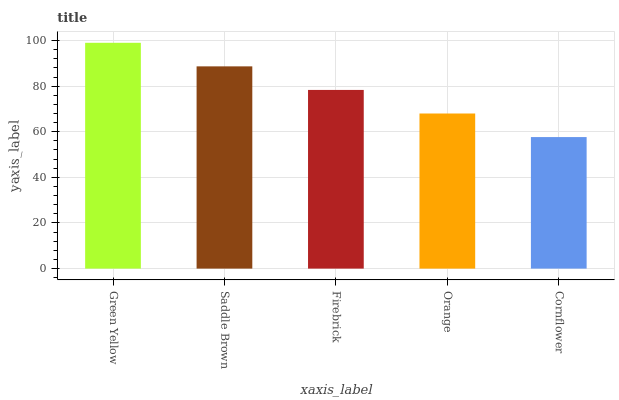Is Cornflower the minimum?
Answer yes or no. Yes. Is Green Yellow the maximum?
Answer yes or no. Yes. Is Saddle Brown the minimum?
Answer yes or no. No. Is Saddle Brown the maximum?
Answer yes or no. No. Is Green Yellow greater than Saddle Brown?
Answer yes or no. Yes. Is Saddle Brown less than Green Yellow?
Answer yes or no. Yes. Is Saddle Brown greater than Green Yellow?
Answer yes or no. No. Is Green Yellow less than Saddle Brown?
Answer yes or no. No. Is Firebrick the high median?
Answer yes or no. Yes. Is Firebrick the low median?
Answer yes or no. Yes. Is Cornflower the high median?
Answer yes or no. No. Is Orange the low median?
Answer yes or no. No. 